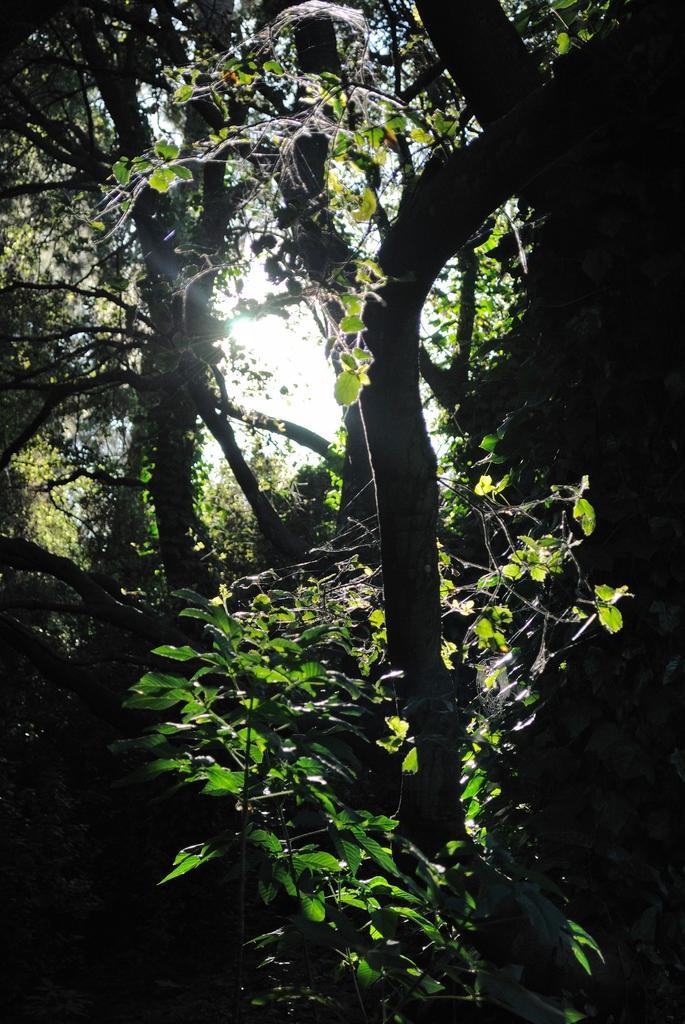Can you describe this image briefly? In this image we can see some plants, trees and the sky. 